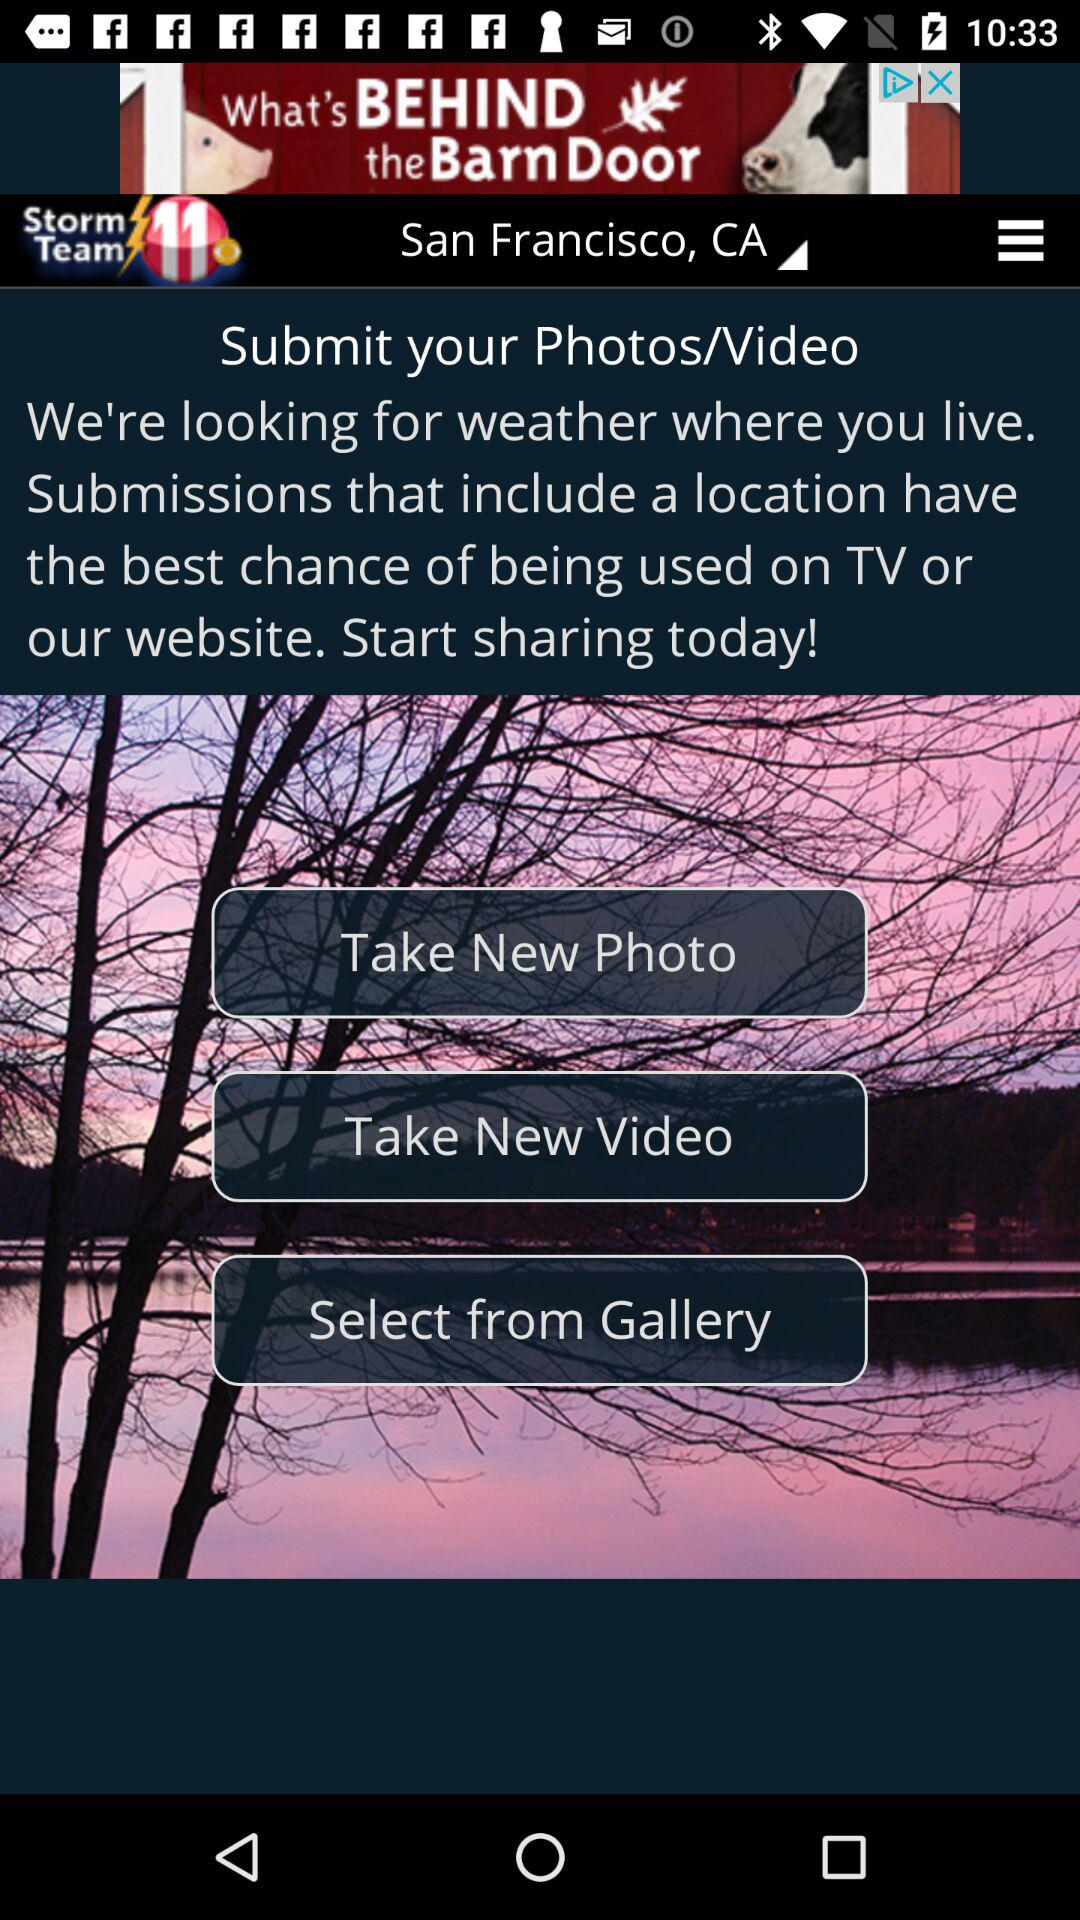Which location is selected? The selected location is San Francisco, CA. 